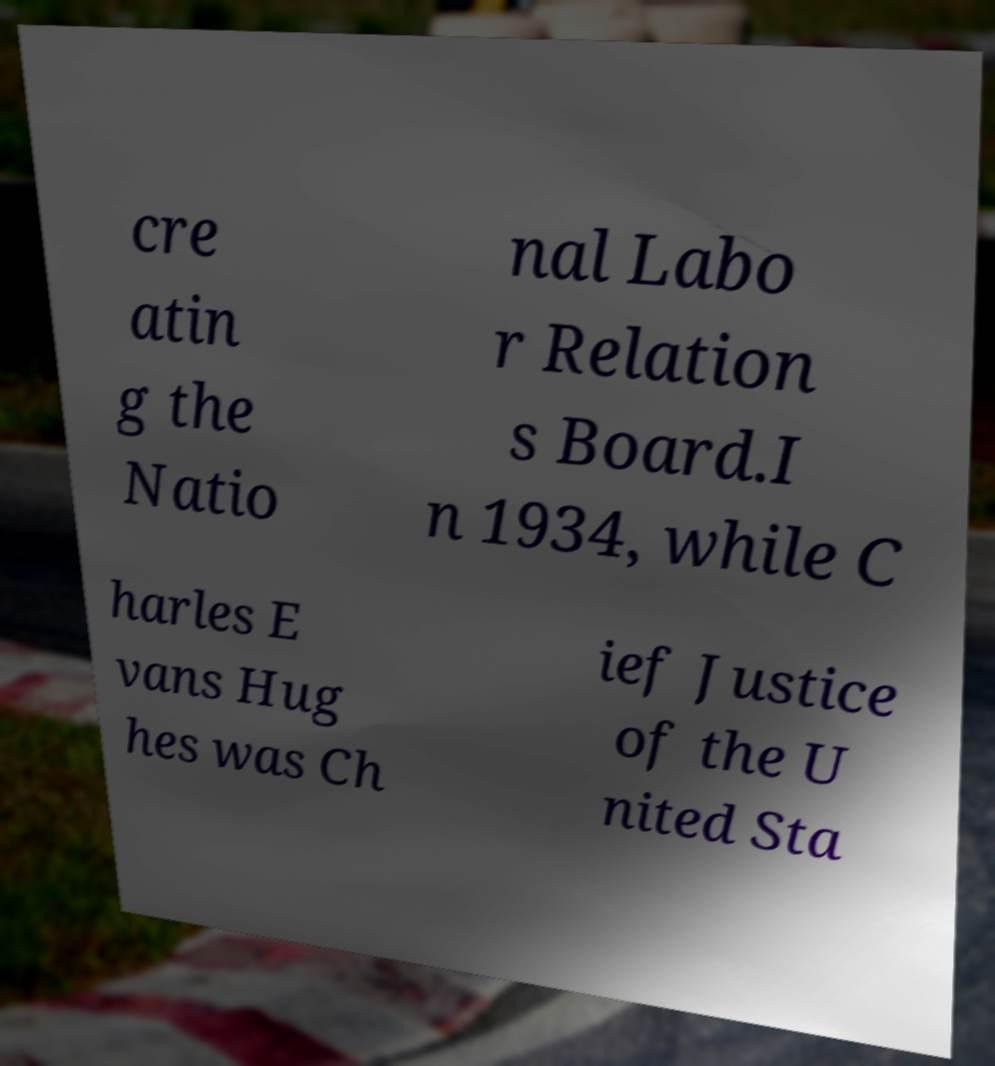Can you read and provide the text displayed in the image?This photo seems to have some interesting text. Can you extract and type it out for me? cre atin g the Natio nal Labo r Relation s Board.I n 1934, while C harles E vans Hug hes was Ch ief Justice of the U nited Sta 